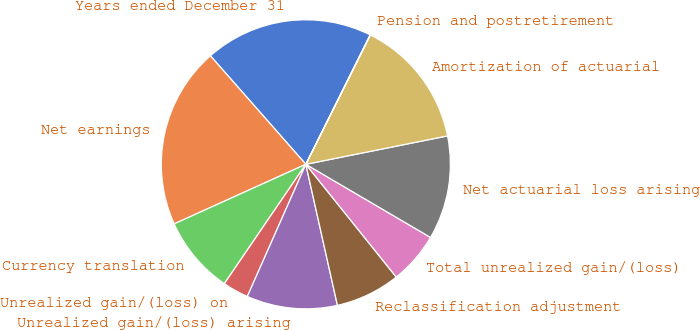Convert chart. <chart><loc_0><loc_0><loc_500><loc_500><pie_chart><fcel>Years ended December 31<fcel>Net earnings<fcel>Currency translation<fcel>Unrealized gain/(loss) on<fcel>Unrealized gain/(loss) arising<fcel>Reclassification adjustment<fcel>Total unrealized gain/(loss)<fcel>Net actuarial loss arising<fcel>Amortization of actuarial<fcel>Pension and postretirement<nl><fcel>18.83%<fcel>20.28%<fcel>8.7%<fcel>2.9%<fcel>10.14%<fcel>7.25%<fcel>5.8%<fcel>11.59%<fcel>14.49%<fcel>0.01%<nl></chart> 